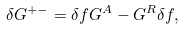<formula> <loc_0><loc_0><loc_500><loc_500>\delta G ^ { + - } = \delta f G ^ { A } - G ^ { R } \delta f ,</formula> 